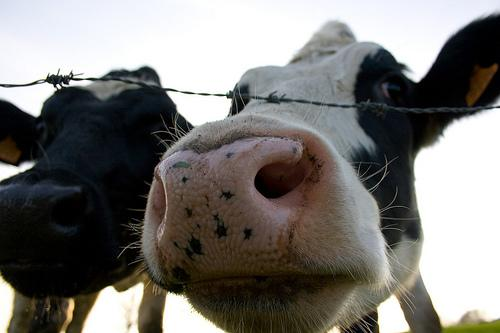Describe the primary elements of this image through the perspective of a nature enthusiast. The image captures the close-up view of a cow's face, focusing on its moist nose and whiskers, seen through the strands of a barbed wire fence. The background features another cow and a hint of a clear sky, emphasizing a serene, pastoral setting. Mention the setting of the image and the objects that make up the foreground. The setting of the image is a pastoral scene where cows are behind a barbed wire fence. The foreground prominently features the barbed wire fence and the detailed nose and whiskers of a cow. Provide a general overview of the scene depicted in the image. The image shows a close-up of a cow's face, particularly its nose and whiskers, viewed through a barbed wire fence. Another cow and a clear sky are visible in the background, creating a peaceful rural atmosphere. Explain the image using a simple and concise language. The image shows a cow's nose and whiskers close-up through a barbed wire fence, with another cow and the sky in the background. Express the main features of the image using a poetic language style. Beneath the vast, clear sky, a cow's curious nose presses against the confines of a barbed wire, whispering tales of the meadow's gentle whispers and the freedom just beyond reach. Describe the color and appearance of the cows in the image. The prominent cow in the image has a black and white face with a pink nose sprinkled with black spots, surrounded by fine whiskers. The other cow in the background also appears to be black and white. What are some distinguishing features of the cows in this image? The cow in the foreground features a distinctly pink nose with black spots and fine whiskers, framed by the black and white patterns of its face. The background hints at another cow, also black and white, contributing to the pastoral feel of the scene. Create a sentence that describes the spatial arrangement of the cows and the fence in the image. A cow with a detailed, spotted nose and whiskers is framed closely by a barbed wire fence, with another cow partially visible in the serene background. Write a brief description of the image with an emphasis on the facial features of the cows. The image focuses on a cow's detailed facial features, showcasing its spotted pink nose and delicate whiskers through the barrier of a barbed wire fence, with another cow's presence softly in the background. Summarize the image by highlighting the central focus and surrounding details. The image captures a close-up view of a cow's face, focusing on its pink, spotted nose and whiskers through a barbed wire fence, with another cow and a clear sky subtly present in the background. 